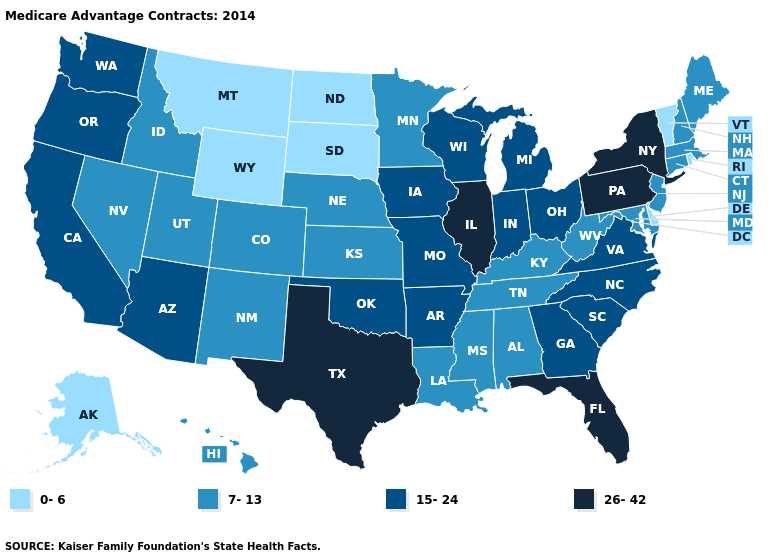Name the states that have a value in the range 15-24?
Quick response, please. Arkansas, Arizona, California, Georgia, Iowa, Indiana, Michigan, Missouri, North Carolina, Ohio, Oklahoma, Oregon, South Carolina, Virginia, Washington, Wisconsin. What is the highest value in states that border Texas?
Write a very short answer. 15-24. Does Montana have the lowest value in the West?
Quick response, please. Yes. Name the states that have a value in the range 7-13?
Give a very brief answer. Alabama, Colorado, Connecticut, Hawaii, Idaho, Kansas, Kentucky, Louisiana, Massachusetts, Maryland, Maine, Minnesota, Mississippi, Nebraska, New Hampshire, New Jersey, New Mexico, Nevada, Tennessee, Utah, West Virginia. Which states hav the highest value in the South?
Keep it brief. Florida, Texas. Which states have the highest value in the USA?
Be succinct. Florida, Illinois, New York, Pennsylvania, Texas. Name the states that have a value in the range 15-24?
Short answer required. Arkansas, Arizona, California, Georgia, Iowa, Indiana, Michigan, Missouri, North Carolina, Ohio, Oklahoma, Oregon, South Carolina, Virginia, Washington, Wisconsin. What is the highest value in the Northeast ?
Be succinct. 26-42. Name the states that have a value in the range 7-13?
Give a very brief answer. Alabama, Colorado, Connecticut, Hawaii, Idaho, Kansas, Kentucky, Louisiana, Massachusetts, Maryland, Maine, Minnesota, Mississippi, Nebraska, New Hampshire, New Jersey, New Mexico, Nevada, Tennessee, Utah, West Virginia. How many symbols are there in the legend?
Be succinct. 4. Among the states that border Tennessee , which have the lowest value?
Keep it brief. Alabama, Kentucky, Mississippi. What is the highest value in the South ?
Answer briefly. 26-42. Which states have the lowest value in the USA?
Write a very short answer. Alaska, Delaware, Montana, North Dakota, Rhode Island, South Dakota, Vermont, Wyoming. Name the states that have a value in the range 0-6?
Concise answer only. Alaska, Delaware, Montana, North Dakota, Rhode Island, South Dakota, Vermont, Wyoming. Among the states that border Indiana , which have the highest value?
Quick response, please. Illinois. 